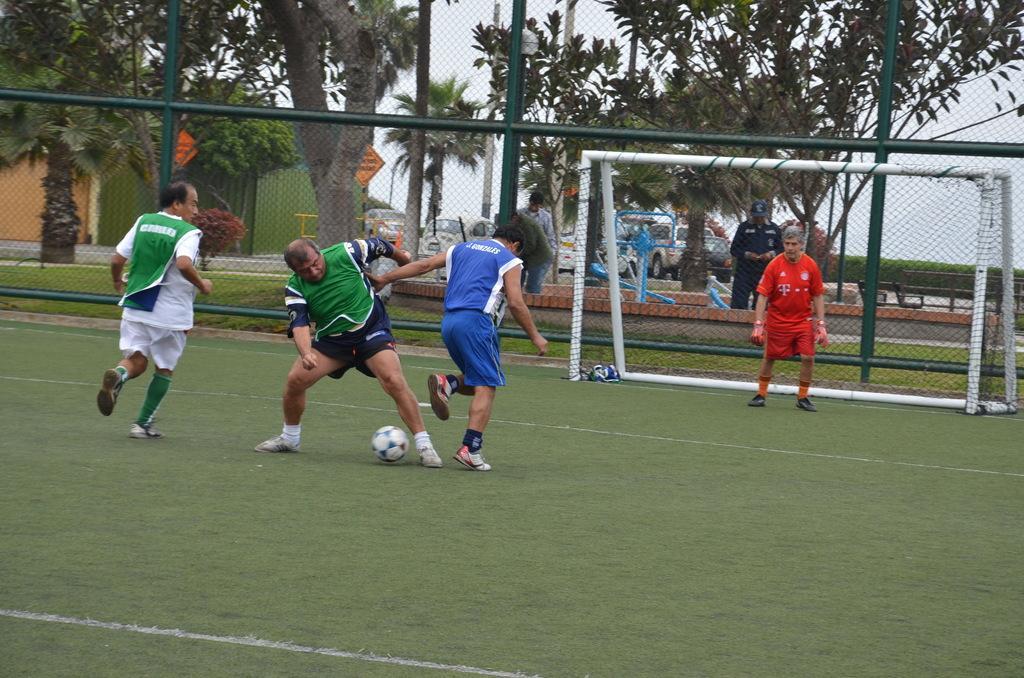Could you give a brief overview of what you see in this image? In this image I can see people among them some are playing football and one man is standing on the ground. In the background I can see fence, a net, a ball, people, trees and houses. I can also see the sky and other objects. 